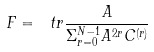<formula> <loc_0><loc_0><loc_500><loc_500>F = \ t r \frac { A } { \Sigma _ { r = 0 } ^ { N - 1 } A ^ { 2 r } C ^ { ( r ) } }</formula> 